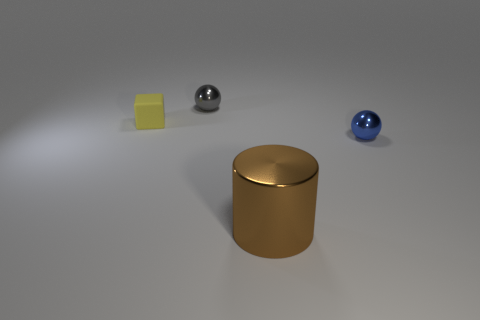Add 4 big red matte objects. How many objects exist? 8 Subtract all blue spheres. How many spheres are left? 1 Subtract 0 yellow cylinders. How many objects are left? 4 Subtract all blocks. How many objects are left? 3 Subtract 1 cylinders. How many cylinders are left? 0 Subtract all blue balls. Subtract all purple cubes. How many balls are left? 1 Subtract all purple cylinders. How many red cubes are left? 0 Subtract all small yellow cubes. Subtract all big green matte blocks. How many objects are left? 3 Add 3 gray metallic balls. How many gray metallic balls are left? 4 Add 1 small yellow cubes. How many small yellow cubes exist? 2 